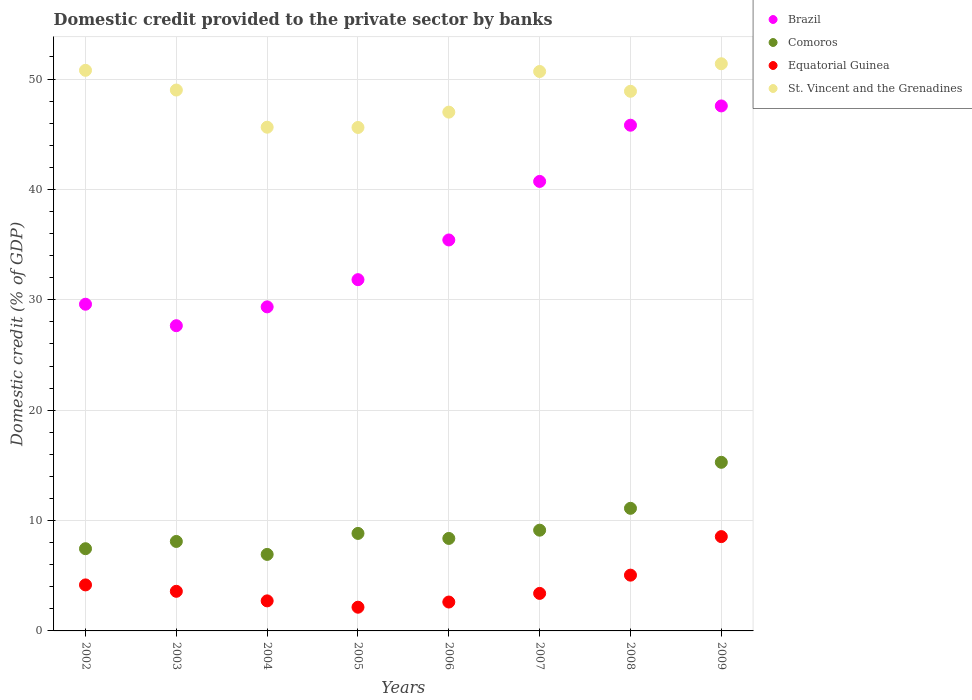What is the domestic credit provided to the private sector by banks in Equatorial Guinea in 2006?
Give a very brief answer. 2.62. Across all years, what is the maximum domestic credit provided to the private sector by banks in Brazil?
Ensure brevity in your answer.  47.56. Across all years, what is the minimum domestic credit provided to the private sector by banks in St. Vincent and the Grenadines?
Offer a terse response. 45.61. In which year was the domestic credit provided to the private sector by banks in Brazil minimum?
Offer a very short reply. 2003. What is the total domestic credit provided to the private sector by banks in Comoros in the graph?
Make the answer very short. 75.21. What is the difference between the domestic credit provided to the private sector by banks in Equatorial Guinea in 2002 and that in 2003?
Make the answer very short. 0.58. What is the difference between the domestic credit provided to the private sector by banks in Equatorial Guinea in 2009 and the domestic credit provided to the private sector by banks in Comoros in 2007?
Make the answer very short. -0.58. What is the average domestic credit provided to the private sector by banks in Brazil per year?
Keep it short and to the point. 35.99. In the year 2003, what is the difference between the domestic credit provided to the private sector by banks in Comoros and domestic credit provided to the private sector by banks in Brazil?
Your answer should be very brief. -19.55. In how many years, is the domestic credit provided to the private sector by banks in Equatorial Guinea greater than 28 %?
Provide a short and direct response. 0. What is the ratio of the domestic credit provided to the private sector by banks in Equatorial Guinea in 2005 to that in 2009?
Give a very brief answer. 0.25. What is the difference between the highest and the second highest domestic credit provided to the private sector by banks in Equatorial Guinea?
Provide a succinct answer. 3.49. What is the difference between the highest and the lowest domestic credit provided to the private sector by banks in St. Vincent and the Grenadines?
Your answer should be very brief. 5.77. In how many years, is the domestic credit provided to the private sector by banks in Equatorial Guinea greater than the average domestic credit provided to the private sector by banks in Equatorial Guinea taken over all years?
Offer a terse response. 3. Is it the case that in every year, the sum of the domestic credit provided to the private sector by banks in Equatorial Guinea and domestic credit provided to the private sector by banks in Brazil  is greater than the domestic credit provided to the private sector by banks in Comoros?
Offer a terse response. Yes. Is the domestic credit provided to the private sector by banks in Comoros strictly less than the domestic credit provided to the private sector by banks in Brazil over the years?
Provide a succinct answer. Yes. How many dotlines are there?
Provide a short and direct response. 4. How many years are there in the graph?
Provide a succinct answer. 8. What is the difference between two consecutive major ticks on the Y-axis?
Provide a succinct answer. 10. Are the values on the major ticks of Y-axis written in scientific E-notation?
Offer a very short reply. No. Where does the legend appear in the graph?
Give a very brief answer. Top right. How many legend labels are there?
Provide a short and direct response. 4. What is the title of the graph?
Keep it short and to the point. Domestic credit provided to the private sector by banks. What is the label or title of the Y-axis?
Provide a succinct answer. Domestic credit (% of GDP). What is the Domestic credit (% of GDP) in Brazil in 2002?
Make the answer very short. 29.6. What is the Domestic credit (% of GDP) of Comoros in 2002?
Your answer should be compact. 7.45. What is the Domestic credit (% of GDP) of Equatorial Guinea in 2002?
Offer a very short reply. 4.17. What is the Domestic credit (% of GDP) in St. Vincent and the Grenadines in 2002?
Your answer should be very brief. 50.79. What is the Domestic credit (% of GDP) of Brazil in 2003?
Offer a very short reply. 27.65. What is the Domestic credit (% of GDP) of Comoros in 2003?
Offer a terse response. 8.11. What is the Domestic credit (% of GDP) of Equatorial Guinea in 2003?
Keep it short and to the point. 3.59. What is the Domestic credit (% of GDP) of St. Vincent and the Grenadines in 2003?
Make the answer very short. 49. What is the Domestic credit (% of GDP) in Brazil in 2004?
Your response must be concise. 29.36. What is the Domestic credit (% of GDP) of Comoros in 2004?
Your response must be concise. 6.93. What is the Domestic credit (% of GDP) of Equatorial Guinea in 2004?
Keep it short and to the point. 2.72. What is the Domestic credit (% of GDP) in St. Vincent and the Grenadines in 2004?
Offer a terse response. 45.64. What is the Domestic credit (% of GDP) in Brazil in 2005?
Offer a very short reply. 31.82. What is the Domestic credit (% of GDP) in Comoros in 2005?
Provide a short and direct response. 8.83. What is the Domestic credit (% of GDP) of Equatorial Guinea in 2005?
Provide a short and direct response. 2.15. What is the Domestic credit (% of GDP) of St. Vincent and the Grenadines in 2005?
Ensure brevity in your answer.  45.61. What is the Domestic credit (% of GDP) of Brazil in 2006?
Offer a terse response. 35.42. What is the Domestic credit (% of GDP) of Comoros in 2006?
Offer a very short reply. 8.38. What is the Domestic credit (% of GDP) of Equatorial Guinea in 2006?
Offer a terse response. 2.62. What is the Domestic credit (% of GDP) in St. Vincent and the Grenadines in 2006?
Give a very brief answer. 47. What is the Domestic credit (% of GDP) in Brazil in 2007?
Make the answer very short. 40.72. What is the Domestic credit (% of GDP) in Comoros in 2007?
Your response must be concise. 9.13. What is the Domestic credit (% of GDP) in Equatorial Guinea in 2007?
Offer a terse response. 3.4. What is the Domestic credit (% of GDP) of St. Vincent and the Grenadines in 2007?
Make the answer very short. 50.68. What is the Domestic credit (% of GDP) in Brazil in 2008?
Offer a terse response. 45.82. What is the Domestic credit (% of GDP) of Comoros in 2008?
Give a very brief answer. 11.11. What is the Domestic credit (% of GDP) in Equatorial Guinea in 2008?
Your answer should be compact. 5.05. What is the Domestic credit (% of GDP) of St. Vincent and the Grenadines in 2008?
Keep it short and to the point. 48.89. What is the Domestic credit (% of GDP) of Brazil in 2009?
Your answer should be compact. 47.56. What is the Domestic credit (% of GDP) in Comoros in 2009?
Your response must be concise. 15.28. What is the Domestic credit (% of GDP) of Equatorial Guinea in 2009?
Keep it short and to the point. 8.54. What is the Domestic credit (% of GDP) in St. Vincent and the Grenadines in 2009?
Provide a succinct answer. 51.38. Across all years, what is the maximum Domestic credit (% of GDP) in Brazil?
Ensure brevity in your answer.  47.56. Across all years, what is the maximum Domestic credit (% of GDP) of Comoros?
Make the answer very short. 15.28. Across all years, what is the maximum Domestic credit (% of GDP) in Equatorial Guinea?
Provide a short and direct response. 8.54. Across all years, what is the maximum Domestic credit (% of GDP) in St. Vincent and the Grenadines?
Your response must be concise. 51.38. Across all years, what is the minimum Domestic credit (% of GDP) in Brazil?
Your answer should be very brief. 27.65. Across all years, what is the minimum Domestic credit (% of GDP) in Comoros?
Give a very brief answer. 6.93. Across all years, what is the minimum Domestic credit (% of GDP) in Equatorial Guinea?
Offer a terse response. 2.15. Across all years, what is the minimum Domestic credit (% of GDP) of St. Vincent and the Grenadines?
Ensure brevity in your answer.  45.61. What is the total Domestic credit (% of GDP) in Brazil in the graph?
Your response must be concise. 287.95. What is the total Domestic credit (% of GDP) in Comoros in the graph?
Your answer should be very brief. 75.21. What is the total Domestic credit (% of GDP) of Equatorial Guinea in the graph?
Give a very brief answer. 32.24. What is the total Domestic credit (% of GDP) of St. Vincent and the Grenadines in the graph?
Your answer should be compact. 389. What is the difference between the Domestic credit (% of GDP) in Brazil in 2002 and that in 2003?
Keep it short and to the point. 1.95. What is the difference between the Domestic credit (% of GDP) of Comoros in 2002 and that in 2003?
Keep it short and to the point. -0.66. What is the difference between the Domestic credit (% of GDP) of Equatorial Guinea in 2002 and that in 2003?
Your answer should be very brief. 0.58. What is the difference between the Domestic credit (% of GDP) in St. Vincent and the Grenadines in 2002 and that in 2003?
Offer a terse response. 1.79. What is the difference between the Domestic credit (% of GDP) of Brazil in 2002 and that in 2004?
Your answer should be compact. 0.24. What is the difference between the Domestic credit (% of GDP) in Comoros in 2002 and that in 2004?
Keep it short and to the point. 0.52. What is the difference between the Domestic credit (% of GDP) in Equatorial Guinea in 2002 and that in 2004?
Your answer should be compact. 1.45. What is the difference between the Domestic credit (% of GDP) in St. Vincent and the Grenadines in 2002 and that in 2004?
Offer a terse response. 5.15. What is the difference between the Domestic credit (% of GDP) of Brazil in 2002 and that in 2005?
Provide a short and direct response. -2.23. What is the difference between the Domestic credit (% of GDP) of Comoros in 2002 and that in 2005?
Provide a succinct answer. -1.39. What is the difference between the Domestic credit (% of GDP) in Equatorial Guinea in 2002 and that in 2005?
Give a very brief answer. 2.02. What is the difference between the Domestic credit (% of GDP) in St. Vincent and the Grenadines in 2002 and that in 2005?
Provide a succinct answer. 5.18. What is the difference between the Domestic credit (% of GDP) of Brazil in 2002 and that in 2006?
Ensure brevity in your answer.  -5.82. What is the difference between the Domestic credit (% of GDP) in Comoros in 2002 and that in 2006?
Ensure brevity in your answer.  -0.93. What is the difference between the Domestic credit (% of GDP) of Equatorial Guinea in 2002 and that in 2006?
Make the answer very short. 1.55. What is the difference between the Domestic credit (% of GDP) in St. Vincent and the Grenadines in 2002 and that in 2006?
Offer a very short reply. 3.79. What is the difference between the Domestic credit (% of GDP) in Brazil in 2002 and that in 2007?
Keep it short and to the point. -11.13. What is the difference between the Domestic credit (% of GDP) in Comoros in 2002 and that in 2007?
Offer a very short reply. -1.68. What is the difference between the Domestic credit (% of GDP) in Equatorial Guinea in 2002 and that in 2007?
Your answer should be very brief. 0.77. What is the difference between the Domestic credit (% of GDP) of St. Vincent and the Grenadines in 2002 and that in 2007?
Provide a short and direct response. 0.11. What is the difference between the Domestic credit (% of GDP) of Brazil in 2002 and that in 2008?
Provide a succinct answer. -16.22. What is the difference between the Domestic credit (% of GDP) in Comoros in 2002 and that in 2008?
Provide a succinct answer. -3.66. What is the difference between the Domestic credit (% of GDP) in Equatorial Guinea in 2002 and that in 2008?
Give a very brief answer. -0.88. What is the difference between the Domestic credit (% of GDP) in St. Vincent and the Grenadines in 2002 and that in 2008?
Make the answer very short. 1.9. What is the difference between the Domestic credit (% of GDP) in Brazil in 2002 and that in 2009?
Your answer should be compact. -17.97. What is the difference between the Domestic credit (% of GDP) in Comoros in 2002 and that in 2009?
Provide a succinct answer. -7.83. What is the difference between the Domestic credit (% of GDP) in Equatorial Guinea in 2002 and that in 2009?
Provide a short and direct response. -4.37. What is the difference between the Domestic credit (% of GDP) of St. Vincent and the Grenadines in 2002 and that in 2009?
Keep it short and to the point. -0.6. What is the difference between the Domestic credit (% of GDP) of Brazil in 2003 and that in 2004?
Offer a very short reply. -1.71. What is the difference between the Domestic credit (% of GDP) of Comoros in 2003 and that in 2004?
Offer a very short reply. 1.17. What is the difference between the Domestic credit (% of GDP) of Equatorial Guinea in 2003 and that in 2004?
Keep it short and to the point. 0.87. What is the difference between the Domestic credit (% of GDP) in St. Vincent and the Grenadines in 2003 and that in 2004?
Give a very brief answer. 3.37. What is the difference between the Domestic credit (% of GDP) in Brazil in 2003 and that in 2005?
Your answer should be compact. -4.17. What is the difference between the Domestic credit (% of GDP) of Comoros in 2003 and that in 2005?
Your answer should be compact. -0.73. What is the difference between the Domestic credit (% of GDP) in Equatorial Guinea in 2003 and that in 2005?
Provide a succinct answer. 1.44. What is the difference between the Domestic credit (% of GDP) in St. Vincent and the Grenadines in 2003 and that in 2005?
Give a very brief answer. 3.39. What is the difference between the Domestic credit (% of GDP) of Brazil in 2003 and that in 2006?
Provide a succinct answer. -7.77. What is the difference between the Domestic credit (% of GDP) of Comoros in 2003 and that in 2006?
Your answer should be very brief. -0.27. What is the difference between the Domestic credit (% of GDP) of Equatorial Guinea in 2003 and that in 2006?
Make the answer very short. 0.97. What is the difference between the Domestic credit (% of GDP) of St. Vincent and the Grenadines in 2003 and that in 2006?
Your response must be concise. 2. What is the difference between the Domestic credit (% of GDP) in Brazil in 2003 and that in 2007?
Provide a short and direct response. -13.07. What is the difference between the Domestic credit (% of GDP) in Comoros in 2003 and that in 2007?
Offer a terse response. -1.02. What is the difference between the Domestic credit (% of GDP) in Equatorial Guinea in 2003 and that in 2007?
Provide a succinct answer. 0.19. What is the difference between the Domestic credit (% of GDP) in St. Vincent and the Grenadines in 2003 and that in 2007?
Your answer should be compact. -1.68. What is the difference between the Domestic credit (% of GDP) in Brazil in 2003 and that in 2008?
Your response must be concise. -18.16. What is the difference between the Domestic credit (% of GDP) of Comoros in 2003 and that in 2008?
Give a very brief answer. -3. What is the difference between the Domestic credit (% of GDP) of Equatorial Guinea in 2003 and that in 2008?
Offer a terse response. -1.46. What is the difference between the Domestic credit (% of GDP) in St. Vincent and the Grenadines in 2003 and that in 2008?
Your response must be concise. 0.11. What is the difference between the Domestic credit (% of GDP) of Brazil in 2003 and that in 2009?
Provide a succinct answer. -19.91. What is the difference between the Domestic credit (% of GDP) of Comoros in 2003 and that in 2009?
Provide a short and direct response. -7.17. What is the difference between the Domestic credit (% of GDP) in Equatorial Guinea in 2003 and that in 2009?
Offer a very short reply. -4.96. What is the difference between the Domestic credit (% of GDP) of St. Vincent and the Grenadines in 2003 and that in 2009?
Keep it short and to the point. -2.38. What is the difference between the Domestic credit (% of GDP) in Brazil in 2004 and that in 2005?
Your answer should be very brief. -2.46. What is the difference between the Domestic credit (% of GDP) of Comoros in 2004 and that in 2005?
Your answer should be very brief. -1.9. What is the difference between the Domestic credit (% of GDP) in Equatorial Guinea in 2004 and that in 2005?
Keep it short and to the point. 0.57. What is the difference between the Domestic credit (% of GDP) in St. Vincent and the Grenadines in 2004 and that in 2005?
Ensure brevity in your answer.  0.02. What is the difference between the Domestic credit (% of GDP) of Brazil in 2004 and that in 2006?
Provide a succinct answer. -6.06. What is the difference between the Domestic credit (% of GDP) in Comoros in 2004 and that in 2006?
Your answer should be compact. -1.45. What is the difference between the Domestic credit (% of GDP) in Equatorial Guinea in 2004 and that in 2006?
Provide a short and direct response. 0.1. What is the difference between the Domestic credit (% of GDP) in St. Vincent and the Grenadines in 2004 and that in 2006?
Your answer should be very brief. -1.37. What is the difference between the Domestic credit (% of GDP) of Brazil in 2004 and that in 2007?
Provide a short and direct response. -11.37. What is the difference between the Domestic credit (% of GDP) of Comoros in 2004 and that in 2007?
Make the answer very short. -2.2. What is the difference between the Domestic credit (% of GDP) of Equatorial Guinea in 2004 and that in 2007?
Offer a terse response. -0.68. What is the difference between the Domestic credit (% of GDP) of St. Vincent and the Grenadines in 2004 and that in 2007?
Offer a terse response. -5.05. What is the difference between the Domestic credit (% of GDP) of Brazil in 2004 and that in 2008?
Provide a succinct answer. -16.46. What is the difference between the Domestic credit (% of GDP) in Comoros in 2004 and that in 2008?
Your answer should be very brief. -4.18. What is the difference between the Domestic credit (% of GDP) of Equatorial Guinea in 2004 and that in 2008?
Make the answer very short. -2.33. What is the difference between the Domestic credit (% of GDP) in St. Vincent and the Grenadines in 2004 and that in 2008?
Keep it short and to the point. -3.25. What is the difference between the Domestic credit (% of GDP) in Brazil in 2004 and that in 2009?
Your answer should be compact. -18.21. What is the difference between the Domestic credit (% of GDP) in Comoros in 2004 and that in 2009?
Your response must be concise. -8.34. What is the difference between the Domestic credit (% of GDP) in Equatorial Guinea in 2004 and that in 2009?
Your response must be concise. -5.82. What is the difference between the Domestic credit (% of GDP) of St. Vincent and the Grenadines in 2004 and that in 2009?
Keep it short and to the point. -5.75. What is the difference between the Domestic credit (% of GDP) in Brazil in 2005 and that in 2006?
Provide a short and direct response. -3.6. What is the difference between the Domestic credit (% of GDP) of Comoros in 2005 and that in 2006?
Keep it short and to the point. 0.45. What is the difference between the Domestic credit (% of GDP) in Equatorial Guinea in 2005 and that in 2006?
Provide a succinct answer. -0.47. What is the difference between the Domestic credit (% of GDP) of St. Vincent and the Grenadines in 2005 and that in 2006?
Your response must be concise. -1.39. What is the difference between the Domestic credit (% of GDP) of Brazil in 2005 and that in 2007?
Your response must be concise. -8.9. What is the difference between the Domestic credit (% of GDP) of Comoros in 2005 and that in 2007?
Offer a very short reply. -0.29. What is the difference between the Domestic credit (% of GDP) in Equatorial Guinea in 2005 and that in 2007?
Offer a very short reply. -1.25. What is the difference between the Domestic credit (% of GDP) in St. Vincent and the Grenadines in 2005 and that in 2007?
Your answer should be compact. -5.07. What is the difference between the Domestic credit (% of GDP) of Brazil in 2005 and that in 2008?
Keep it short and to the point. -13.99. What is the difference between the Domestic credit (% of GDP) in Comoros in 2005 and that in 2008?
Provide a succinct answer. -2.27. What is the difference between the Domestic credit (% of GDP) of Equatorial Guinea in 2005 and that in 2008?
Make the answer very short. -2.9. What is the difference between the Domestic credit (% of GDP) in St. Vincent and the Grenadines in 2005 and that in 2008?
Ensure brevity in your answer.  -3.28. What is the difference between the Domestic credit (% of GDP) in Brazil in 2005 and that in 2009?
Offer a terse response. -15.74. What is the difference between the Domestic credit (% of GDP) of Comoros in 2005 and that in 2009?
Offer a terse response. -6.44. What is the difference between the Domestic credit (% of GDP) of Equatorial Guinea in 2005 and that in 2009?
Keep it short and to the point. -6.4. What is the difference between the Domestic credit (% of GDP) in St. Vincent and the Grenadines in 2005 and that in 2009?
Give a very brief answer. -5.77. What is the difference between the Domestic credit (% of GDP) of Brazil in 2006 and that in 2007?
Offer a terse response. -5.3. What is the difference between the Domestic credit (% of GDP) in Comoros in 2006 and that in 2007?
Keep it short and to the point. -0.75. What is the difference between the Domestic credit (% of GDP) in Equatorial Guinea in 2006 and that in 2007?
Ensure brevity in your answer.  -0.78. What is the difference between the Domestic credit (% of GDP) in St. Vincent and the Grenadines in 2006 and that in 2007?
Offer a terse response. -3.68. What is the difference between the Domestic credit (% of GDP) of Brazil in 2006 and that in 2008?
Keep it short and to the point. -10.4. What is the difference between the Domestic credit (% of GDP) of Comoros in 2006 and that in 2008?
Your answer should be compact. -2.73. What is the difference between the Domestic credit (% of GDP) of Equatorial Guinea in 2006 and that in 2008?
Your response must be concise. -2.44. What is the difference between the Domestic credit (% of GDP) in St. Vincent and the Grenadines in 2006 and that in 2008?
Offer a terse response. -1.89. What is the difference between the Domestic credit (% of GDP) of Brazil in 2006 and that in 2009?
Make the answer very short. -12.14. What is the difference between the Domestic credit (% of GDP) of Comoros in 2006 and that in 2009?
Keep it short and to the point. -6.9. What is the difference between the Domestic credit (% of GDP) in Equatorial Guinea in 2006 and that in 2009?
Your answer should be compact. -5.93. What is the difference between the Domestic credit (% of GDP) in St. Vincent and the Grenadines in 2006 and that in 2009?
Make the answer very short. -4.38. What is the difference between the Domestic credit (% of GDP) in Brazil in 2007 and that in 2008?
Keep it short and to the point. -5.09. What is the difference between the Domestic credit (% of GDP) of Comoros in 2007 and that in 2008?
Provide a short and direct response. -1.98. What is the difference between the Domestic credit (% of GDP) of Equatorial Guinea in 2007 and that in 2008?
Give a very brief answer. -1.65. What is the difference between the Domestic credit (% of GDP) in St. Vincent and the Grenadines in 2007 and that in 2008?
Provide a short and direct response. 1.79. What is the difference between the Domestic credit (% of GDP) of Brazil in 2007 and that in 2009?
Offer a very short reply. -6.84. What is the difference between the Domestic credit (% of GDP) of Comoros in 2007 and that in 2009?
Keep it short and to the point. -6.15. What is the difference between the Domestic credit (% of GDP) of Equatorial Guinea in 2007 and that in 2009?
Your answer should be very brief. -5.14. What is the difference between the Domestic credit (% of GDP) of St. Vincent and the Grenadines in 2007 and that in 2009?
Your response must be concise. -0.7. What is the difference between the Domestic credit (% of GDP) of Brazil in 2008 and that in 2009?
Give a very brief answer. -1.75. What is the difference between the Domestic credit (% of GDP) in Comoros in 2008 and that in 2009?
Give a very brief answer. -4.17. What is the difference between the Domestic credit (% of GDP) of Equatorial Guinea in 2008 and that in 2009?
Provide a succinct answer. -3.49. What is the difference between the Domestic credit (% of GDP) in St. Vincent and the Grenadines in 2008 and that in 2009?
Keep it short and to the point. -2.49. What is the difference between the Domestic credit (% of GDP) of Brazil in 2002 and the Domestic credit (% of GDP) of Comoros in 2003?
Your answer should be very brief. 21.49. What is the difference between the Domestic credit (% of GDP) in Brazil in 2002 and the Domestic credit (% of GDP) in Equatorial Guinea in 2003?
Your response must be concise. 26.01. What is the difference between the Domestic credit (% of GDP) in Brazil in 2002 and the Domestic credit (% of GDP) in St. Vincent and the Grenadines in 2003?
Keep it short and to the point. -19.41. What is the difference between the Domestic credit (% of GDP) of Comoros in 2002 and the Domestic credit (% of GDP) of Equatorial Guinea in 2003?
Give a very brief answer. 3.86. What is the difference between the Domestic credit (% of GDP) in Comoros in 2002 and the Domestic credit (% of GDP) in St. Vincent and the Grenadines in 2003?
Provide a short and direct response. -41.55. What is the difference between the Domestic credit (% of GDP) in Equatorial Guinea in 2002 and the Domestic credit (% of GDP) in St. Vincent and the Grenadines in 2003?
Your answer should be very brief. -44.83. What is the difference between the Domestic credit (% of GDP) of Brazil in 2002 and the Domestic credit (% of GDP) of Comoros in 2004?
Make the answer very short. 22.67. What is the difference between the Domestic credit (% of GDP) of Brazil in 2002 and the Domestic credit (% of GDP) of Equatorial Guinea in 2004?
Provide a succinct answer. 26.88. What is the difference between the Domestic credit (% of GDP) in Brazil in 2002 and the Domestic credit (% of GDP) in St. Vincent and the Grenadines in 2004?
Provide a succinct answer. -16.04. What is the difference between the Domestic credit (% of GDP) in Comoros in 2002 and the Domestic credit (% of GDP) in Equatorial Guinea in 2004?
Make the answer very short. 4.73. What is the difference between the Domestic credit (% of GDP) in Comoros in 2002 and the Domestic credit (% of GDP) in St. Vincent and the Grenadines in 2004?
Your answer should be compact. -38.19. What is the difference between the Domestic credit (% of GDP) of Equatorial Guinea in 2002 and the Domestic credit (% of GDP) of St. Vincent and the Grenadines in 2004?
Keep it short and to the point. -41.47. What is the difference between the Domestic credit (% of GDP) in Brazil in 2002 and the Domestic credit (% of GDP) in Comoros in 2005?
Keep it short and to the point. 20.76. What is the difference between the Domestic credit (% of GDP) of Brazil in 2002 and the Domestic credit (% of GDP) of Equatorial Guinea in 2005?
Ensure brevity in your answer.  27.45. What is the difference between the Domestic credit (% of GDP) in Brazil in 2002 and the Domestic credit (% of GDP) in St. Vincent and the Grenadines in 2005?
Provide a short and direct response. -16.01. What is the difference between the Domestic credit (% of GDP) of Comoros in 2002 and the Domestic credit (% of GDP) of Equatorial Guinea in 2005?
Your answer should be compact. 5.3. What is the difference between the Domestic credit (% of GDP) of Comoros in 2002 and the Domestic credit (% of GDP) of St. Vincent and the Grenadines in 2005?
Make the answer very short. -38.16. What is the difference between the Domestic credit (% of GDP) in Equatorial Guinea in 2002 and the Domestic credit (% of GDP) in St. Vincent and the Grenadines in 2005?
Offer a terse response. -41.44. What is the difference between the Domestic credit (% of GDP) in Brazil in 2002 and the Domestic credit (% of GDP) in Comoros in 2006?
Offer a very short reply. 21.22. What is the difference between the Domestic credit (% of GDP) in Brazil in 2002 and the Domestic credit (% of GDP) in Equatorial Guinea in 2006?
Provide a short and direct response. 26.98. What is the difference between the Domestic credit (% of GDP) in Brazil in 2002 and the Domestic credit (% of GDP) in St. Vincent and the Grenadines in 2006?
Your answer should be compact. -17.4. What is the difference between the Domestic credit (% of GDP) in Comoros in 2002 and the Domestic credit (% of GDP) in Equatorial Guinea in 2006?
Offer a very short reply. 4.83. What is the difference between the Domestic credit (% of GDP) in Comoros in 2002 and the Domestic credit (% of GDP) in St. Vincent and the Grenadines in 2006?
Offer a very short reply. -39.55. What is the difference between the Domestic credit (% of GDP) of Equatorial Guinea in 2002 and the Domestic credit (% of GDP) of St. Vincent and the Grenadines in 2006?
Ensure brevity in your answer.  -42.83. What is the difference between the Domestic credit (% of GDP) of Brazil in 2002 and the Domestic credit (% of GDP) of Comoros in 2007?
Offer a very short reply. 20.47. What is the difference between the Domestic credit (% of GDP) of Brazil in 2002 and the Domestic credit (% of GDP) of Equatorial Guinea in 2007?
Provide a succinct answer. 26.2. What is the difference between the Domestic credit (% of GDP) in Brazil in 2002 and the Domestic credit (% of GDP) in St. Vincent and the Grenadines in 2007?
Offer a terse response. -21.09. What is the difference between the Domestic credit (% of GDP) in Comoros in 2002 and the Domestic credit (% of GDP) in Equatorial Guinea in 2007?
Give a very brief answer. 4.05. What is the difference between the Domestic credit (% of GDP) in Comoros in 2002 and the Domestic credit (% of GDP) in St. Vincent and the Grenadines in 2007?
Provide a succinct answer. -43.23. What is the difference between the Domestic credit (% of GDP) in Equatorial Guinea in 2002 and the Domestic credit (% of GDP) in St. Vincent and the Grenadines in 2007?
Provide a short and direct response. -46.51. What is the difference between the Domestic credit (% of GDP) in Brazil in 2002 and the Domestic credit (% of GDP) in Comoros in 2008?
Provide a short and direct response. 18.49. What is the difference between the Domestic credit (% of GDP) of Brazil in 2002 and the Domestic credit (% of GDP) of Equatorial Guinea in 2008?
Your answer should be very brief. 24.54. What is the difference between the Domestic credit (% of GDP) of Brazil in 2002 and the Domestic credit (% of GDP) of St. Vincent and the Grenadines in 2008?
Offer a very short reply. -19.29. What is the difference between the Domestic credit (% of GDP) in Comoros in 2002 and the Domestic credit (% of GDP) in Equatorial Guinea in 2008?
Your answer should be very brief. 2.4. What is the difference between the Domestic credit (% of GDP) of Comoros in 2002 and the Domestic credit (% of GDP) of St. Vincent and the Grenadines in 2008?
Make the answer very short. -41.44. What is the difference between the Domestic credit (% of GDP) of Equatorial Guinea in 2002 and the Domestic credit (% of GDP) of St. Vincent and the Grenadines in 2008?
Ensure brevity in your answer.  -44.72. What is the difference between the Domestic credit (% of GDP) in Brazil in 2002 and the Domestic credit (% of GDP) in Comoros in 2009?
Provide a short and direct response. 14.32. What is the difference between the Domestic credit (% of GDP) of Brazil in 2002 and the Domestic credit (% of GDP) of Equatorial Guinea in 2009?
Offer a very short reply. 21.05. What is the difference between the Domestic credit (% of GDP) in Brazil in 2002 and the Domestic credit (% of GDP) in St. Vincent and the Grenadines in 2009?
Make the answer very short. -21.79. What is the difference between the Domestic credit (% of GDP) of Comoros in 2002 and the Domestic credit (% of GDP) of Equatorial Guinea in 2009?
Offer a very short reply. -1.1. What is the difference between the Domestic credit (% of GDP) of Comoros in 2002 and the Domestic credit (% of GDP) of St. Vincent and the Grenadines in 2009?
Your response must be concise. -43.94. What is the difference between the Domestic credit (% of GDP) in Equatorial Guinea in 2002 and the Domestic credit (% of GDP) in St. Vincent and the Grenadines in 2009?
Your answer should be compact. -47.22. What is the difference between the Domestic credit (% of GDP) of Brazil in 2003 and the Domestic credit (% of GDP) of Comoros in 2004?
Offer a very short reply. 20.72. What is the difference between the Domestic credit (% of GDP) in Brazil in 2003 and the Domestic credit (% of GDP) in Equatorial Guinea in 2004?
Keep it short and to the point. 24.93. What is the difference between the Domestic credit (% of GDP) in Brazil in 2003 and the Domestic credit (% of GDP) in St. Vincent and the Grenadines in 2004?
Offer a very short reply. -17.98. What is the difference between the Domestic credit (% of GDP) in Comoros in 2003 and the Domestic credit (% of GDP) in Equatorial Guinea in 2004?
Provide a succinct answer. 5.38. What is the difference between the Domestic credit (% of GDP) of Comoros in 2003 and the Domestic credit (% of GDP) of St. Vincent and the Grenadines in 2004?
Provide a short and direct response. -37.53. What is the difference between the Domestic credit (% of GDP) in Equatorial Guinea in 2003 and the Domestic credit (% of GDP) in St. Vincent and the Grenadines in 2004?
Keep it short and to the point. -42.05. What is the difference between the Domestic credit (% of GDP) in Brazil in 2003 and the Domestic credit (% of GDP) in Comoros in 2005?
Your response must be concise. 18.82. What is the difference between the Domestic credit (% of GDP) of Brazil in 2003 and the Domestic credit (% of GDP) of Equatorial Guinea in 2005?
Your answer should be compact. 25.5. What is the difference between the Domestic credit (% of GDP) in Brazil in 2003 and the Domestic credit (% of GDP) in St. Vincent and the Grenadines in 2005?
Your answer should be compact. -17.96. What is the difference between the Domestic credit (% of GDP) of Comoros in 2003 and the Domestic credit (% of GDP) of Equatorial Guinea in 2005?
Your response must be concise. 5.96. What is the difference between the Domestic credit (% of GDP) of Comoros in 2003 and the Domestic credit (% of GDP) of St. Vincent and the Grenadines in 2005?
Your answer should be very brief. -37.51. What is the difference between the Domestic credit (% of GDP) in Equatorial Guinea in 2003 and the Domestic credit (% of GDP) in St. Vincent and the Grenadines in 2005?
Provide a short and direct response. -42.02. What is the difference between the Domestic credit (% of GDP) in Brazil in 2003 and the Domestic credit (% of GDP) in Comoros in 2006?
Provide a succinct answer. 19.27. What is the difference between the Domestic credit (% of GDP) in Brazil in 2003 and the Domestic credit (% of GDP) in Equatorial Guinea in 2006?
Offer a terse response. 25.03. What is the difference between the Domestic credit (% of GDP) in Brazil in 2003 and the Domestic credit (% of GDP) in St. Vincent and the Grenadines in 2006?
Make the answer very short. -19.35. What is the difference between the Domestic credit (% of GDP) of Comoros in 2003 and the Domestic credit (% of GDP) of Equatorial Guinea in 2006?
Keep it short and to the point. 5.49. What is the difference between the Domestic credit (% of GDP) of Comoros in 2003 and the Domestic credit (% of GDP) of St. Vincent and the Grenadines in 2006?
Keep it short and to the point. -38.9. What is the difference between the Domestic credit (% of GDP) in Equatorial Guinea in 2003 and the Domestic credit (% of GDP) in St. Vincent and the Grenadines in 2006?
Your answer should be very brief. -43.41. What is the difference between the Domestic credit (% of GDP) of Brazil in 2003 and the Domestic credit (% of GDP) of Comoros in 2007?
Your response must be concise. 18.52. What is the difference between the Domestic credit (% of GDP) in Brazil in 2003 and the Domestic credit (% of GDP) in Equatorial Guinea in 2007?
Make the answer very short. 24.25. What is the difference between the Domestic credit (% of GDP) in Brazil in 2003 and the Domestic credit (% of GDP) in St. Vincent and the Grenadines in 2007?
Provide a succinct answer. -23.03. What is the difference between the Domestic credit (% of GDP) in Comoros in 2003 and the Domestic credit (% of GDP) in Equatorial Guinea in 2007?
Your answer should be very brief. 4.71. What is the difference between the Domestic credit (% of GDP) of Comoros in 2003 and the Domestic credit (% of GDP) of St. Vincent and the Grenadines in 2007?
Provide a short and direct response. -42.58. What is the difference between the Domestic credit (% of GDP) of Equatorial Guinea in 2003 and the Domestic credit (% of GDP) of St. Vincent and the Grenadines in 2007?
Provide a succinct answer. -47.09. What is the difference between the Domestic credit (% of GDP) in Brazil in 2003 and the Domestic credit (% of GDP) in Comoros in 2008?
Give a very brief answer. 16.54. What is the difference between the Domestic credit (% of GDP) in Brazil in 2003 and the Domestic credit (% of GDP) in Equatorial Guinea in 2008?
Make the answer very short. 22.6. What is the difference between the Domestic credit (% of GDP) of Brazil in 2003 and the Domestic credit (% of GDP) of St. Vincent and the Grenadines in 2008?
Offer a terse response. -21.24. What is the difference between the Domestic credit (% of GDP) in Comoros in 2003 and the Domestic credit (% of GDP) in Equatorial Guinea in 2008?
Offer a terse response. 3.05. What is the difference between the Domestic credit (% of GDP) in Comoros in 2003 and the Domestic credit (% of GDP) in St. Vincent and the Grenadines in 2008?
Your response must be concise. -40.78. What is the difference between the Domestic credit (% of GDP) of Equatorial Guinea in 2003 and the Domestic credit (% of GDP) of St. Vincent and the Grenadines in 2008?
Ensure brevity in your answer.  -45.3. What is the difference between the Domestic credit (% of GDP) in Brazil in 2003 and the Domestic credit (% of GDP) in Comoros in 2009?
Your answer should be compact. 12.38. What is the difference between the Domestic credit (% of GDP) of Brazil in 2003 and the Domestic credit (% of GDP) of Equatorial Guinea in 2009?
Provide a succinct answer. 19.11. What is the difference between the Domestic credit (% of GDP) of Brazil in 2003 and the Domestic credit (% of GDP) of St. Vincent and the Grenadines in 2009?
Provide a succinct answer. -23.73. What is the difference between the Domestic credit (% of GDP) in Comoros in 2003 and the Domestic credit (% of GDP) in Equatorial Guinea in 2009?
Offer a very short reply. -0.44. What is the difference between the Domestic credit (% of GDP) of Comoros in 2003 and the Domestic credit (% of GDP) of St. Vincent and the Grenadines in 2009?
Your answer should be very brief. -43.28. What is the difference between the Domestic credit (% of GDP) in Equatorial Guinea in 2003 and the Domestic credit (% of GDP) in St. Vincent and the Grenadines in 2009?
Your answer should be compact. -47.8. What is the difference between the Domestic credit (% of GDP) in Brazil in 2004 and the Domestic credit (% of GDP) in Comoros in 2005?
Keep it short and to the point. 20.52. What is the difference between the Domestic credit (% of GDP) in Brazil in 2004 and the Domestic credit (% of GDP) in Equatorial Guinea in 2005?
Provide a succinct answer. 27.21. What is the difference between the Domestic credit (% of GDP) in Brazil in 2004 and the Domestic credit (% of GDP) in St. Vincent and the Grenadines in 2005?
Your answer should be very brief. -16.25. What is the difference between the Domestic credit (% of GDP) of Comoros in 2004 and the Domestic credit (% of GDP) of Equatorial Guinea in 2005?
Provide a succinct answer. 4.78. What is the difference between the Domestic credit (% of GDP) of Comoros in 2004 and the Domestic credit (% of GDP) of St. Vincent and the Grenadines in 2005?
Ensure brevity in your answer.  -38.68. What is the difference between the Domestic credit (% of GDP) in Equatorial Guinea in 2004 and the Domestic credit (% of GDP) in St. Vincent and the Grenadines in 2005?
Offer a very short reply. -42.89. What is the difference between the Domestic credit (% of GDP) of Brazil in 2004 and the Domestic credit (% of GDP) of Comoros in 2006?
Your answer should be very brief. 20.98. What is the difference between the Domestic credit (% of GDP) of Brazil in 2004 and the Domestic credit (% of GDP) of Equatorial Guinea in 2006?
Offer a very short reply. 26.74. What is the difference between the Domestic credit (% of GDP) of Brazil in 2004 and the Domestic credit (% of GDP) of St. Vincent and the Grenadines in 2006?
Offer a terse response. -17.64. What is the difference between the Domestic credit (% of GDP) of Comoros in 2004 and the Domestic credit (% of GDP) of Equatorial Guinea in 2006?
Keep it short and to the point. 4.31. What is the difference between the Domestic credit (% of GDP) of Comoros in 2004 and the Domestic credit (% of GDP) of St. Vincent and the Grenadines in 2006?
Offer a very short reply. -40.07. What is the difference between the Domestic credit (% of GDP) of Equatorial Guinea in 2004 and the Domestic credit (% of GDP) of St. Vincent and the Grenadines in 2006?
Provide a succinct answer. -44.28. What is the difference between the Domestic credit (% of GDP) in Brazil in 2004 and the Domestic credit (% of GDP) in Comoros in 2007?
Your answer should be compact. 20.23. What is the difference between the Domestic credit (% of GDP) of Brazil in 2004 and the Domestic credit (% of GDP) of Equatorial Guinea in 2007?
Provide a short and direct response. 25.96. What is the difference between the Domestic credit (% of GDP) in Brazil in 2004 and the Domestic credit (% of GDP) in St. Vincent and the Grenadines in 2007?
Your answer should be very brief. -21.32. What is the difference between the Domestic credit (% of GDP) in Comoros in 2004 and the Domestic credit (% of GDP) in Equatorial Guinea in 2007?
Ensure brevity in your answer.  3.53. What is the difference between the Domestic credit (% of GDP) in Comoros in 2004 and the Domestic credit (% of GDP) in St. Vincent and the Grenadines in 2007?
Your answer should be compact. -43.75. What is the difference between the Domestic credit (% of GDP) in Equatorial Guinea in 2004 and the Domestic credit (% of GDP) in St. Vincent and the Grenadines in 2007?
Provide a succinct answer. -47.96. What is the difference between the Domestic credit (% of GDP) of Brazil in 2004 and the Domestic credit (% of GDP) of Comoros in 2008?
Offer a very short reply. 18.25. What is the difference between the Domestic credit (% of GDP) of Brazil in 2004 and the Domestic credit (% of GDP) of Equatorial Guinea in 2008?
Your response must be concise. 24.31. What is the difference between the Domestic credit (% of GDP) in Brazil in 2004 and the Domestic credit (% of GDP) in St. Vincent and the Grenadines in 2008?
Offer a very short reply. -19.53. What is the difference between the Domestic credit (% of GDP) of Comoros in 2004 and the Domestic credit (% of GDP) of Equatorial Guinea in 2008?
Keep it short and to the point. 1.88. What is the difference between the Domestic credit (% of GDP) of Comoros in 2004 and the Domestic credit (% of GDP) of St. Vincent and the Grenadines in 2008?
Offer a very short reply. -41.96. What is the difference between the Domestic credit (% of GDP) of Equatorial Guinea in 2004 and the Domestic credit (% of GDP) of St. Vincent and the Grenadines in 2008?
Your answer should be compact. -46.17. What is the difference between the Domestic credit (% of GDP) of Brazil in 2004 and the Domestic credit (% of GDP) of Comoros in 2009?
Ensure brevity in your answer.  14.08. What is the difference between the Domestic credit (% of GDP) of Brazil in 2004 and the Domestic credit (% of GDP) of Equatorial Guinea in 2009?
Your response must be concise. 20.81. What is the difference between the Domestic credit (% of GDP) in Brazil in 2004 and the Domestic credit (% of GDP) in St. Vincent and the Grenadines in 2009?
Offer a terse response. -22.03. What is the difference between the Domestic credit (% of GDP) of Comoros in 2004 and the Domestic credit (% of GDP) of Equatorial Guinea in 2009?
Offer a terse response. -1.61. What is the difference between the Domestic credit (% of GDP) in Comoros in 2004 and the Domestic credit (% of GDP) in St. Vincent and the Grenadines in 2009?
Provide a short and direct response. -44.45. What is the difference between the Domestic credit (% of GDP) in Equatorial Guinea in 2004 and the Domestic credit (% of GDP) in St. Vincent and the Grenadines in 2009?
Provide a succinct answer. -48.66. What is the difference between the Domestic credit (% of GDP) in Brazil in 2005 and the Domestic credit (% of GDP) in Comoros in 2006?
Make the answer very short. 23.44. What is the difference between the Domestic credit (% of GDP) of Brazil in 2005 and the Domestic credit (% of GDP) of Equatorial Guinea in 2006?
Offer a terse response. 29.21. What is the difference between the Domestic credit (% of GDP) of Brazil in 2005 and the Domestic credit (% of GDP) of St. Vincent and the Grenadines in 2006?
Provide a succinct answer. -15.18. What is the difference between the Domestic credit (% of GDP) in Comoros in 2005 and the Domestic credit (% of GDP) in Equatorial Guinea in 2006?
Ensure brevity in your answer.  6.22. What is the difference between the Domestic credit (% of GDP) of Comoros in 2005 and the Domestic credit (% of GDP) of St. Vincent and the Grenadines in 2006?
Provide a succinct answer. -38.17. What is the difference between the Domestic credit (% of GDP) of Equatorial Guinea in 2005 and the Domestic credit (% of GDP) of St. Vincent and the Grenadines in 2006?
Keep it short and to the point. -44.85. What is the difference between the Domestic credit (% of GDP) in Brazil in 2005 and the Domestic credit (% of GDP) in Comoros in 2007?
Your response must be concise. 22.7. What is the difference between the Domestic credit (% of GDP) in Brazil in 2005 and the Domestic credit (% of GDP) in Equatorial Guinea in 2007?
Make the answer very short. 28.42. What is the difference between the Domestic credit (% of GDP) of Brazil in 2005 and the Domestic credit (% of GDP) of St. Vincent and the Grenadines in 2007?
Ensure brevity in your answer.  -18.86. What is the difference between the Domestic credit (% of GDP) in Comoros in 2005 and the Domestic credit (% of GDP) in Equatorial Guinea in 2007?
Offer a very short reply. 5.43. What is the difference between the Domestic credit (% of GDP) of Comoros in 2005 and the Domestic credit (% of GDP) of St. Vincent and the Grenadines in 2007?
Your answer should be very brief. -41.85. What is the difference between the Domestic credit (% of GDP) of Equatorial Guinea in 2005 and the Domestic credit (% of GDP) of St. Vincent and the Grenadines in 2007?
Provide a short and direct response. -48.53. What is the difference between the Domestic credit (% of GDP) of Brazil in 2005 and the Domestic credit (% of GDP) of Comoros in 2008?
Offer a very short reply. 20.72. What is the difference between the Domestic credit (% of GDP) in Brazil in 2005 and the Domestic credit (% of GDP) in Equatorial Guinea in 2008?
Ensure brevity in your answer.  26.77. What is the difference between the Domestic credit (% of GDP) of Brazil in 2005 and the Domestic credit (% of GDP) of St. Vincent and the Grenadines in 2008?
Offer a very short reply. -17.07. What is the difference between the Domestic credit (% of GDP) of Comoros in 2005 and the Domestic credit (% of GDP) of Equatorial Guinea in 2008?
Your answer should be very brief. 3.78. What is the difference between the Domestic credit (% of GDP) of Comoros in 2005 and the Domestic credit (% of GDP) of St. Vincent and the Grenadines in 2008?
Provide a succinct answer. -40.06. What is the difference between the Domestic credit (% of GDP) of Equatorial Guinea in 2005 and the Domestic credit (% of GDP) of St. Vincent and the Grenadines in 2008?
Make the answer very short. -46.74. What is the difference between the Domestic credit (% of GDP) of Brazil in 2005 and the Domestic credit (% of GDP) of Comoros in 2009?
Offer a terse response. 16.55. What is the difference between the Domestic credit (% of GDP) in Brazil in 2005 and the Domestic credit (% of GDP) in Equatorial Guinea in 2009?
Ensure brevity in your answer.  23.28. What is the difference between the Domestic credit (% of GDP) in Brazil in 2005 and the Domestic credit (% of GDP) in St. Vincent and the Grenadines in 2009?
Provide a short and direct response. -19.56. What is the difference between the Domestic credit (% of GDP) of Comoros in 2005 and the Domestic credit (% of GDP) of Equatorial Guinea in 2009?
Keep it short and to the point. 0.29. What is the difference between the Domestic credit (% of GDP) in Comoros in 2005 and the Domestic credit (% of GDP) in St. Vincent and the Grenadines in 2009?
Provide a short and direct response. -42.55. What is the difference between the Domestic credit (% of GDP) in Equatorial Guinea in 2005 and the Domestic credit (% of GDP) in St. Vincent and the Grenadines in 2009?
Your answer should be very brief. -49.24. What is the difference between the Domestic credit (% of GDP) in Brazil in 2006 and the Domestic credit (% of GDP) in Comoros in 2007?
Ensure brevity in your answer.  26.29. What is the difference between the Domestic credit (% of GDP) in Brazil in 2006 and the Domestic credit (% of GDP) in Equatorial Guinea in 2007?
Provide a succinct answer. 32.02. What is the difference between the Domestic credit (% of GDP) in Brazil in 2006 and the Domestic credit (% of GDP) in St. Vincent and the Grenadines in 2007?
Give a very brief answer. -15.26. What is the difference between the Domestic credit (% of GDP) in Comoros in 2006 and the Domestic credit (% of GDP) in Equatorial Guinea in 2007?
Make the answer very short. 4.98. What is the difference between the Domestic credit (% of GDP) in Comoros in 2006 and the Domestic credit (% of GDP) in St. Vincent and the Grenadines in 2007?
Offer a terse response. -42.3. What is the difference between the Domestic credit (% of GDP) of Equatorial Guinea in 2006 and the Domestic credit (% of GDP) of St. Vincent and the Grenadines in 2007?
Make the answer very short. -48.07. What is the difference between the Domestic credit (% of GDP) in Brazil in 2006 and the Domestic credit (% of GDP) in Comoros in 2008?
Ensure brevity in your answer.  24.31. What is the difference between the Domestic credit (% of GDP) in Brazil in 2006 and the Domestic credit (% of GDP) in Equatorial Guinea in 2008?
Make the answer very short. 30.37. What is the difference between the Domestic credit (% of GDP) in Brazil in 2006 and the Domestic credit (% of GDP) in St. Vincent and the Grenadines in 2008?
Offer a terse response. -13.47. What is the difference between the Domestic credit (% of GDP) of Comoros in 2006 and the Domestic credit (% of GDP) of Equatorial Guinea in 2008?
Give a very brief answer. 3.33. What is the difference between the Domestic credit (% of GDP) in Comoros in 2006 and the Domestic credit (% of GDP) in St. Vincent and the Grenadines in 2008?
Your answer should be very brief. -40.51. What is the difference between the Domestic credit (% of GDP) of Equatorial Guinea in 2006 and the Domestic credit (% of GDP) of St. Vincent and the Grenadines in 2008?
Provide a succinct answer. -46.27. What is the difference between the Domestic credit (% of GDP) in Brazil in 2006 and the Domestic credit (% of GDP) in Comoros in 2009?
Your response must be concise. 20.14. What is the difference between the Domestic credit (% of GDP) in Brazil in 2006 and the Domestic credit (% of GDP) in Equatorial Guinea in 2009?
Provide a short and direct response. 26.88. What is the difference between the Domestic credit (% of GDP) of Brazil in 2006 and the Domestic credit (% of GDP) of St. Vincent and the Grenadines in 2009?
Offer a terse response. -15.96. What is the difference between the Domestic credit (% of GDP) of Comoros in 2006 and the Domestic credit (% of GDP) of Equatorial Guinea in 2009?
Ensure brevity in your answer.  -0.16. What is the difference between the Domestic credit (% of GDP) in Comoros in 2006 and the Domestic credit (% of GDP) in St. Vincent and the Grenadines in 2009?
Provide a short and direct response. -43.01. What is the difference between the Domestic credit (% of GDP) of Equatorial Guinea in 2006 and the Domestic credit (% of GDP) of St. Vincent and the Grenadines in 2009?
Offer a very short reply. -48.77. What is the difference between the Domestic credit (% of GDP) of Brazil in 2007 and the Domestic credit (% of GDP) of Comoros in 2008?
Your response must be concise. 29.62. What is the difference between the Domestic credit (% of GDP) of Brazil in 2007 and the Domestic credit (% of GDP) of Equatorial Guinea in 2008?
Your answer should be compact. 35.67. What is the difference between the Domestic credit (% of GDP) in Brazil in 2007 and the Domestic credit (% of GDP) in St. Vincent and the Grenadines in 2008?
Your answer should be compact. -8.17. What is the difference between the Domestic credit (% of GDP) in Comoros in 2007 and the Domestic credit (% of GDP) in Equatorial Guinea in 2008?
Make the answer very short. 4.07. What is the difference between the Domestic credit (% of GDP) in Comoros in 2007 and the Domestic credit (% of GDP) in St. Vincent and the Grenadines in 2008?
Give a very brief answer. -39.76. What is the difference between the Domestic credit (% of GDP) in Equatorial Guinea in 2007 and the Domestic credit (% of GDP) in St. Vincent and the Grenadines in 2008?
Give a very brief answer. -45.49. What is the difference between the Domestic credit (% of GDP) of Brazil in 2007 and the Domestic credit (% of GDP) of Comoros in 2009?
Provide a short and direct response. 25.45. What is the difference between the Domestic credit (% of GDP) in Brazil in 2007 and the Domestic credit (% of GDP) in Equatorial Guinea in 2009?
Provide a short and direct response. 32.18. What is the difference between the Domestic credit (% of GDP) in Brazil in 2007 and the Domestic credit (% of GDP) in St. Vincent and the Grenadines in 2009?
Provide a succinct answer. -10.66. What is the difference between the Domestic credit (% of GDP) of Comoros in 2007 and the Domestic credit (% of GDP) of Equatorial Guinea in 2009?
Ensure brevity in your answer.  0.58. What is the difference between the Domestic credit (% of GDP) in Comoros in 2007 and the Domestic credit (% of GDP) in St. Vincent and the Grenadines in 2009?
Offer a very short reply. -42.26. What is the difference between the Domestic credit (% of GDP) in Equatorial Guinea in 2007 and the Domestic credit (% of GDP) in St. Vincent and the Grenadines in 2009?
Provide a short and direct response. -47.99. What is the difference between the Domestic credit (% of GDP) in Brazil in 2008 and the Domestic credit (% of GDP) in Comoros in 2009?
Provide a succinct answer. 30.54. What is the difference between the Domestic credit (% of GDP) of Brazil in 2008 and the Domestic credit (% of GDP) of Equatorial Guinea in 2009?
Your answer should be compact. 37.27. What is the difference between the Domestic credit (% of GDP) in Brazil in 2008 and the Domestic credit (% of GDP) in St. Vincent and the Grenadines in 2009?
Offer a very short reply. -5.57. What is the difference between the Domestic credit (% of GDP) in Comoros in 2008 and the Domestic credit (% of GDP) in Equatorial Guinea in 2009?
Offer a terse response. 2.56. What is the difference between the Domestic credit (% of GDP) of Comoros in 2008 and the Domestic credit (% of GDP) of St. Vincent and the Grenadines in 2009?
Provide a succinct answer. -40.28. What is the difference between the Domestic credit (% of GDP) in Equatorial Guinea in 2008 and the Domestic credit (% of GDP) in St. Vincent and the Grenadines in 2009?
Offer a very short reply. -46.33. What is the average Domestic credit (% of GDP) in Brazil per year?
Your answer should be compact. 35.99. What is the average Domestic credit (% of GDP) in Comoros per year?
Provide a short and direct response. 9.4. What is the average Domestic credit (% of GDP) in Equatorial Guinea per year?
Your answer should be compact. 4.03. What is the average Domestic credit (% of GDP) in St. Vincent and the Grenadines per year?
Provide a succinct answer. 48.62. In the year 2002, what is the difference between the Domestic credit (% of GDP) of Brazil and Domestic credit (% of GDP) of Comoros?
Ensure brevity in your answer.  22.15. In the year 2002, what is the difference between the Domestic credit (% of GDP) in Brazil and Domestic credit (% of GDP) in Equatorial Guinea?
Give a very brief answer. 25.43. In the year 2002, what is the difference between the Domestic credit (% of GDP) in Brazil and Domestic credit (% of GDP) in St. Vincent and the Grenadines?
Keep it short and to the point. -21.19. In the year 2002, what is the difference between the Domestic credit (% of GDP) in Comoros and Domestic credit (% of GDP) in Equatorial Guinea?
Your answer should be compact. 3.28. In the year 2002, what is the difference between the Domestic credit (% of GDP) in Comoros and Domestic credit (% of GDP) in St. Vincent and the Grenadines?
Provide a short and direct response. -43.34. In the year 2002, what is the difference between the Domestic credit (% of GDP) in Equatorial Guinea and Domestic credit (% of GDP) in St. Vincent and the Grenadines?
Give a very brief answer. -46.62. In the year 2003, what is the difference between the Domestic credit (% of GDP) of Brazil and Domestic credit (% of GDP) of Comoros?
Offer a terse response. 19.55. In the year 2003, what is the difference between the Domestic credit (% of GDP) in Brazil and Domestic credit (% of GDP) in Equatorial Guinea?
Make the answer very short. 24.06. In the year 2003, what is the difference between the Domestic credit (% of GDP) in Brazil and Domestic credit (% of GDP) in St. Vincent and the Grenadines?
Offer a very short reply. -21.35. In the year 2003, what is the difference between the Domestic credit (% of GDP) of Comoros and Domestic credit (% of GDP) of Equatorial Guinea?
Make the answer very short. 4.52. In the year 2003, what is the difference between the Domestic credit (% of GDP) of Comoros and Domestic credit (% of GDP) of St. Vincent and the Grenadines?
Your response must be concise. -40.9. In the year 2003, what is the difference between the Domestic credit (% of GDP) of Equatorial Guinea and Domestic credit (% of GDP) of St. Vincent and the Grenadines?
Give a very brief answer. -45.41. In the year 2004, what is the difference between the Domestic credit (% of GDP) of Brazil and Domestic credit (% of GDP) of Comoros?
Your answer should be compact. 22.43. In the year 2004, what is the difference between the Domestic credit (% of GDP) of Brazil and Domestic credit (% of GDP) of Equatorial Guinea?
Give a very brief answer. 26.64. In the year 2004, what is the difference between the Domestic credit (% of GDP) of Brazil and Domestic credit (% of GDP) of St. Vincent and the Grenadines?
Make the answer very short. -16.28. In the year 2004, what is the difference between the Domestic credit (% of GDP) in Comoros and Domestic credit (% of GDP) in Equatorial Guinea?
Keep it short and to the point. 4.21. In the year 2004, what is the difference between the Domestic credit (% of GDP) in Comoros and Domestic credit (% of GDP) in St. Vincent and the Grenadines?
Keep it short and to the point. -38.7. In the year 2004, what is the difference between the Domestic credit (% of GDP) in Equatorial Guinea and Domestic credit (% of GDP) in St. Vincent and the Grenadines?
Offer a very short reply. -42.91. In the year 2005, what is the difference between the Domestic credit (% of GDP) of Brazil and Domestic credit (% of GDP) of Comoros?
Your answer should be compact. 22.99. In the year 2005, what is the difference between the Domestic credit (% of GDP) of Brazil and Domestic credit (% of GDP) of Equatorial Guinea?
Make the answer very short. 29.67. In the year 2005, what is the difference between the Domestic credit (% of GDP) of Brazil and Domestic credit (% of GDP) of St. Vincent and the Grenadines?
Your response must be concise. -13.79. In the year 2005, what is the difference between the Domestic credit (% of GDP) in Comoros and Domestic credit (% of GDP) in Equatorial Guinea?
Ensure brevity in your answer.  6.69. In the year 2005, what is the difference between the Domestic credit (% of GDP) in Comoros and Domestic credit (% of GDP) in St. Vincent and the Grenadines?
Offer a very short reply. -36.78. In the year 2005, what is the difference between the Domestic credit (% of GDP) in Equatorial Guinea and Domestic credit (% of GDP) in St. Vincent and the Grenadines?
Your answer should be very brief. -43.46. In the year 2006, what is the difference between the Domestic credit (% of GDP) in Brazil and Domestic credit (% of GDP) in Comoros?
Provide a succinct answer. 27.04. In the year 2006, what is the difference between the Domestic credit (% of GDP) in Brazil and Domestic credit (% of GDP) in Equatorial Guinea?
Offer a terse response. 32.8. In the year 2006, what is the difference between the Domestic credit (% of GDP) in Brazil and Domestic credit (% of GDP) in St. Vincent and the Grenadines?
Provide a short and direct response. -11.58. In the year 2006, what is the difference between the Domestic credit (% of GDP) in Comoros and Domestic credit (% of GDP) in Equatorial Guinea?
Offer a terse response. 5.76. In the year 2006, what is the difference between the Domestic credit (% of GDP) in Comoros and Domestic credit (% of GDP) in St. Vincent and the Grenadines?
Ensure brevity in your answer.  -38.62. In the year 2006, what is the difference between the Domestic credit (% of GDP) of Equatorial Guinea and Domestic credit (% of GDP) of St. Vincent and the Grenadines?
Provide a short and direct response. -44.38. In the year 2007, what is the difference between the Domestic credit (% of GDP) of Brazil and Domestic credit (% of GDP) of Comoros?
Keep it short and to the point. 31.6. In the year 2007, what is the difference between the Domestic credit (% of GDP) of Brazil and Domestic credit (% of GDP) of Equatorial Guinea?
Your answer should be very brief. 37.32. In the year 2007, what is the difference between the Domestic credit (% of GDP) of Brazil and Domestic credit (% of GDP) of St. Vincent and the Grenadines?
Keep it short and to the point. -9.96. In the year 2007, what is the difference between the Domestic credit (% of GDP) of Comoros and Domestic credit (% of GDP) of Equatorial Guinea?
Ensure brevity in your answer.  5.73. In the year 2007, what is the difference between the Domestic credit (% of GDP) in Comoros and Domestic credit (% of GDP) in St. Vincent and the Grenadines?
Provide a short and direct response. -41.56. In the year 2007, what is the difference between the Domestic credit (% of GDP) in Equatorial Guinea and Domestic credit (% of GDP) in St. Vincent and the Grenadines?
Make the answer very short. -47.28. In the year 2008, what is the difference between the Domestic credit (% of GDP) in Brazil and Domestic credit (% of GDP) in Comoros?
Keep it short and to the point. 34.71. In the year 2008, what is the difference between the Domestic credit (% of GDP) of Brazil and Domestic credit (% of GDP) of Equatorial Guinea?
Make the answer very short. 40.76. In the year 2008, what is the difference between the Domestic credit (% of GDP) in Brazil and Domestic credit (% of GDP) in St. Vincent and the Grenadines?
Make the answer very short. -3.07. In the year 2008, what is the difference between the Domestic credit (% of GDP) of Comoros and Domestic credit (% of GDP) of Equatorial Guinea?
Provide a short and direct response. 6.05. In the year 2008, what is the difference between the Domestic credit (% of GDP) of Comoros and Domestic credit (% of GDP) of St. Vincent and the Grenadines?
Your answer should be very brief. -37.78. In the year 2008, what is the difference between the Domestic credit (% of GDP) in Equatorial Guinea and Domestic credit (% of GDP) in St. Vincent and the Grenadines?
Offer a very short reply. -43.84. In the year 2009, what is the difference between the Domestic credit (% of GDP) of Brazil and Domestic credit (% of GDP) of Comoros?
Provide a succinct answer. 32.29. In the year 2009, what is the difference between the Domestic credit (% of GDP) of Brazil and Domestic credit (% of GDP) of Equatorial Guinea?
Your response must be concise. 39.02. In the year 2009, what is the difference between the Domestic credit (% of GDP) of Brazil and Domestic credit (% of GDP) of St. Vincent and the Grenadines?
Provide a succinct answer. -3.82. In the year 2009, what is the difference between the Domestic credit (% of GDP) in Comoros and Domestic credit (% of GDP) in Equatorial Guinea?
Provide a succinct answer. 6.73. In the year 2009, what is the difference between the Domestic credit (% of GDP) in Comoros and Domestic credit (% of GDP) in St. Vincent and the Grenadines?
Your answer should be compact. -36.11. In the year 2009, what is the difference between the Domestic credit (% of GDP) in Equatorial Guinea and Domestic credit (% of GDP) in St. Vincent and the Grenadines?
Offer a very short reply. -42.84. What is the ratio of the Domestic credit (% of GDP) of Brazil in 2002 to that in 2003?
Provide a short and direct response. 1.07. What is the ratio of the Domestic credit (% of GDP) in Comoros in 2002 to that in 2003?
Your response must be concise. 0.92. What is the ratio of the Domestic credit (% of GDP) of Equatorial Guinea in 2002 to that in 2003?
Offer a terse response. 1.16. What is the ratio of the Domestic credit (% of GDP) in St. Vincent and the Grenadines in 2002 to that in 2003?
Your answer should be very brief. 1.04. What is the ratio of the Domestic credit (% of GDP) of Comoros in 2002 to that in 2004?
Ensure brevity in your answer.  1.07. What is the ratio of the Domestic credit (% of GDP) of Equatorial Guinea in 2002 to that in 2004?
Your answer should be very brief. 1.53. What is the ratio of the Domestic credit (% of GDP) of St. Vincent and the Grenadines in 2002 to that in 2004?
Provide a succinct answer. 1.11. What is the ratio of the Domestic credit (% of GDP) of Brazil in 2002 to that in 2005?
Make the answer very short. 0.93. What is the ratio of the Domestic credit (% of GDP) in Comoros in 2002 to that in 2005?
Give a very brief answer. 0.84. What is the ratio of the Domestic credit (% of GDP) of Equatorial Guinea in 2002 to that in 2005?
Make the answer very short. 1.94. What is the ratio of the Domestic credit (% of GDP) of St. Vincent and the Grenadines in 2002 to that in 2005?
Your response must be concise. 1.11. What is the ratio of the Domestic credit (% of GDP) in Brazil in 2002 to that in 2006?
Your response must be concise. 0.84. What is the ratio of the Domestic credit (% of GDP) in Comoros in 2002 to that in 2006?
Your answer should be compact. 0.89. What is the ratio of the Domestic credit (% of GDP) in Equatorial Guinea in 2002 to that in 2006?
Ensure brevity in your answer.  1.59. What is the ratio of the Domestic credit (% of GDP) in St. Vincent and the Grenadines in 2002 to that in 2006?
Ensure brevity in your answer.  1.08. What is the ratio of the Domestic credit (% of GDP) of Brazil in 2002 to that in 2007?
Your answer should be very brief. 0.73. What is the ratio of the Domestic credit (% of GDP) of Comoros in 2002 to that in 2007?
Keep it short and to the point. 0.82. What is the ratio of the Domestic credit (% of GDP) of Equatorial Guinea in 2002 to that in 2007?
Offer a terse response. 1.23. What is the ratio of the Domestic credit (% of GDP) of Brazil in 2002 to that in 2008?
Your response must be concise. 0.65. What is the ratio of the Domestic credit (% of GDP) in Comoros in 2002 to that in 2008?
Offer a very short reply. 0.67. What is the ratio of the Domestic credit (% of GDP) in Equatorial Guinea in 2002 to that in 2008?
Your response must be concise. 0.83. What is the ratio of the Domestic credit (% of GDP) of St. Vincent and the Grenadines in 2002 to that in 2008?
Give a very brief answer. 1.04. What is the ratio of the Domestic credit (% of GDP) in Brazil in 2002 to that in 2009?
Your answer should be compact. 0.62. What is the ratio of the Domestic credit (% of GDP) of Comoros in 2002 to that in 2009?
Provide a short and direct response. 0.49. What is the ratio of the Domestic credit (% of GDP) of Equatorial Guinea in 2002 to that in 2009?
Your answer should be compact. 0.49. What is the ratio of the Domestic credit (% of GDP) in St. Vincent and the Grenadines in 2002 to that in 2009?
Your answer should be very brief. 0.99. What is the ratio of the Domestic credit (% of GDP) of Brazil in 2003 to that in 2004?
Your answer should be very brief. 0.94. What is the ratio of the Domestic credit (% of GDP) of Comoros in 2003 to that in 2004?
Make the answer very short. 1.17. What is the ratio of the Domestic credit (% of GDP) of Equatorial Guinea in 2003 to that in 2004?
Your answer should be compact. 1.32. What is the ratio of the Domestic credit (% of GDP) of St. Vincent and the Grenadines in 2003 to that in 2004?
Your answer should be compact. 1.07. What is the ratio of the Domestic credit (% of GDP) in Brazil in 2003 to that in 2005?
Your answer should be very brief. 0.87. What is the ratio of the Domestic credit (% of GDP) of Comoros in 2003 to that in 2005?
Offer a terse response. 0.92. What is the ratio of the Domestic credit (% of GDP) of Equatorial Guinea in 2003 to that in 2005?
Your response must be concise. 1.67. What is the ratio of the Domestic credit (% of GDP) in St. Vincent and the Grenadines in 2003 to that in 2005?
Ensure brevity in your answer.  1.07. What is the ratio of the Domestic credit (% of GDP) in Brazil in 2003 to that in 2006?
Offer a very short reply. 0.78. What is the ratio of the Domestic credit (% of GDP) in Comoros in 2003 to that in 2006?
Your answer should be compact. 0.97. What is the ratio of the Domestic credit (% of GDP) of Equatorial Guinea in 2003 to that in 2006?
Make the answer very short. 1.37. What is the ratio of the Domestic credit (% of GDP) in St. Vincent and the Grenadines in 2003 to that in 2006?
Give a very brief answer. 1.04. What is the ratio of the Domestic credit (% of GDP) in Brazil in 2003 to that in 2007?
Provide a succinct answer. 0.68. What is the ratio of the Domestic credit (% of GDP) of Comoros in 2003 to that in 2007?
Provide a short and direct response. 0.89. What is the ratio of the Domestic credit (% of GDP) in Equatorial Guinea in 2003 to that in 2007?
Offer a terse response. 1.06. What is the ratio of the Domestic credit (% of GDP) of St. Vincent and the Grenadines in 2003 to that in 2007?
Make the answer very short. 0.97. What is the ratio of the Domestic credit (% of GDP) of Brazil in 2003 to that in 2008?
Give a very brief answer. 0.6. What is the ratio of the Domestic credit (% of GDP) of Comoros in 2003 to that in 2008?
Offer a terse response. 0.73. What is the ratio of the Domestic credit (% of GDP) in Equatorial Guinea in 2003 to that in 2008?
Ensure brevity in your answer.  0.71. What is the ratio of the Domestic credit (% of GDP) in Brazil in 2003 to that in 2009?
Provide a succinct answer. 0.58. What is the ratio of the Domestic credit (% of GDP) of Comoros in 2003 to that in 2009?
Provide a short and direct response. 0.53. What is the ratio of the Domestic credit (% of GDP) in Equatorial Guinea in 2003 to that in 2009?
Keep it short and to the point. 0.42. What is the ratio of the Domestic credit (% of GDP) in St. Vincent and the Grenadines in 2003 to that in 2009?
Keep it short and to the point. 0.95. What is the ratio of the Domestic credit (% of GDP) of Brazil in 2004 to that in 2005?
Make the answer very short. 0.92. What is the ratio of the Domestic credit (% of GDP) in Comoros in 2004 to that in 2005?
Give a very brief answer. 0.78. What is the ratio of the Domestic credit (% of GDP) of Equatorial Guinea in 2004 to that in 2005?
Your response must be concise. 1.27. What is the ratio of the Domestic credit (% of GDP) of St. Vincent and the Grenadines in 2004 to that in 2005?
Make the answer very short. 1. What is the ratio of the Domestic credit (% of GDP) in Brazil in 2004 to that in 2006?
Offer a very short reply. 0.83. What is the ratio of the Domestic credit (% of GDP) of Comoros in 2004 to that in 2006?
Your answer should be very brief. 0.83. What is the ratio of the Domestic credit (% of GDP) in Equatorial Guinea in 2004 to that in 2006?
Your answer should be compact. 1.04. What is the ratio of the Domestic credit (% of GDP) of St. Vincent and the Grenadines in 2004 to that in 2006?
Provide a short and direct response. 0.97. What is the ratio of the Domestic credit (% of GDP) of Brazil in 2004 to that in 2007?
Keep it short and to the point. 0.72. What is the ratio of the Domestic credit (% of GDP) in Comoros in 2004 to that in 2007?
Offer a very short reply. 0.76. What is the ratio of the Domestic credit (% of GDP) of Equatorial Guinea in 2004 to that in 2007?
Give a very brief answer. 0.8. What is the ratio of the Domestic credit (% of GDP) in St. Vincent and the Grenadines in 2004 to that in 2007?
Offer a terse response. 0.9. What is the ratio of the Domestic credit (% of GDP) in Brazil in 2004 to that in 2008?
Ensure brevity in your answer.  0.64. What is the ratio of the Domestic credit (% of GDP) in Comoros in 2004 to that in 2008?
Your response must be concise. 0.62. What is the ratio of the Domestic credit (% of GDP) in Equatorial Guinea in 2004 to that in 2008?
Keep it short and to the point. 0.54. What is the ratio of the Domestic credit (% of GDP) of St. Vincent and the Grenadines in 2004 to that in 2008?
Make the answer very short. 0.93. What is the ratio of the Domestic credit (% of GDP) of Brazil in 2004 to that in 2009?
Offer a very short reply. 0.62. What is the ratio of the Domestic credit (% of GDP) of Comoros in 2004 to that in 2009?
Your response must be concise. 0.45. What is the ratio of the Domestic credit (% of GDP) in Equatorial Guinea in 2004 to that in 2009?
Make the answer very short. 0.32. What is the ratio of the Domestic credit (% of GDP) of St. Vincent and the Grenadines in 2004 to that in 2009?
Provide a short and direct response. 0.89. What is the ratio of the Domestic credit (% of GDP) in Brazil in 2005 to that in 2006?
Ensure brevity in your answer.  0.9. What is the ratio of the Domestic credit (% of GDP) of Comoros in 2005 to that in 2006?
Provide a succinct answer. 1.05. What is the ratio of the Domestic credit (% of GDP) in Equatorial Guinea in 2005 to that in 2006?
Your answer should be very brief. 0.82. What is the ratio of the Domestic credit (% of GDP) in St. Vincent and the Grenadines in 2005 to that in 2006?
Give a very brief answer. 0.97. What is the ratio of the Domestic credit (% of GDP) in Brazil in 2005 to that in 2007?
Offer a terse response. 0.78. What is the ratio of the Domestic credit (% of GDP) of Comoros in 2005 to that in 2007?
Your answer should be compact. 0.97. What is the ratio of the Domestic credit (% of GDP) of Equatorial Guinea in 2005 to that in 2007?
Your answer should be very brief. 0.63. What is the ratio of the Domestic credit (% of GDP) of St. Vincent and the Grenadines in 2005 to that in 2007?
Offer a very short reply. 0.9. What is the ratio of the Domestic credit (% of GDP) in Brazil in 2005 to that in 2008?
Give a very brief answer. 0.69. What is the ratio of the Domestic credit (% of GDP) of Comoros in 2005 to that in 2008?
Ensure brevity in your answer.  0.8. What is the ratio of the Domestic credit (% of GDP) in Equatorial Guinea in 2005 to that in 2008?
Provide a succinct answer. 0.43. What is the ratio of the Domestic credit (% of GDP) of St. Vincent and the Grenadines in 2005 to that in 2008?
Give a very brief answer. 0.93. What is the ratio of the Domestic credit (% of GDP) of Brazil in 2005 to that in 2009?
Offer a very short reply. 0.67. What is the ratio of the Domestic credit (% of GDP) in Comoros in 2005 to that in 2009?
Provide a succinct answer. 0.58. What is the ratio of the Domestic credit (% of GDP) of Equatorial Guinea in 2005 to that in 2009?
Give a very brief answer. 0.25. What is the ratio of the Domestic credit (% of GDP) of St. Vincent and the Grenadines in 2005 to that in 2009?
Provide a succinct answer. 0.89. What is the ratio of the Domestic credit (% of GDP) of Brazil in 2006 to that in 2007?
Make the answer very short. 0.87. What is the ratio of the Domestic credit (% of GDP) of Comoros in 2006 to that in 2007?
Make the answer very short. 0.92. What is the ratio of the Domestic credit (% of GDP) in Equatorial Guinea in 2006 to that in 2007?
Your answer should be compact. 0.77. What is the ratio of the Domestic credit (% of GDP) of St. Vincent and the Grenadines in 2006 to that in 2007?
Your answer should be compact. 0.93. What is the ratio of the Domestic credit (% of GDP) of Brazil in 2006 to that in 2008?
Make the answer very short. 0.77. What is the ratio of the Domestic credit (% of GDP) of Comoros in 2006 to that in 2008?
Your answer should be very brief. 0.75. What is the ratio of the Domestic credit (% of GDP) of Equatorial Guinea in 2006 to that in 2008?
Offer a terse response. 0.52. What is the ratio of the Domestic credit (% of GDP) of St. Vincent and the Grenadines in 2006 to that in 2008?
Offer a very short reply. 0.96. What is the ratio of the Domestic credit (% of GDP) in Brazil in 2006 to that in 2009?
Your response must be concise. 0.74. What is the ratio of the Domestic credit (% of GDP) in Comoros in 2006 to that in 2009?
Offer a very short reply. 0.55. What is the ratio of the Domestic credit (% of GDP) in Equatorial Guinea in 2006 to that in 2009?
Keep it short and to the point. 0.31. What is the ratio of the Domestic credit (% of GDP) in St. Vincent and the Grenadines in 2006 to that in 2009?
Provide a short and direct response. 0.91. What is the ratio of the Domestic credit (% of GDP) of Brazil in 2007 to that in 2008?
Offer a terse response. 0.89. What is the ratio of the Domestic credit (% of GDP) of Comoros in 2007 to that in 2008?
Your answer should be compact. 0.82. What is the ratio of the Domestic credit (% of GDP) of Equatorial Guinea in 2007 to that in 2008?
Provide a succinct answer. 0.67. What is the ratio of the Domestic credit (% of GDP) of St. Vincent and the Grenadines in 2007 to that in 2008?
Your answer should be very brief. 1.04. What is the ratio of the Domestic credit (% of GDP) of Brazil in 2007 to that in 2009?
Your answer should be compact. 0.86. What is the ratio of the Domestic credit (% of GDP) of Comoros in 2007 to that in 2009?
Make the answer very short. 0.6. What is the ratio of the Domestic credit (% of GDP) in Equatorial Guinea in 2007 to that in 2009?
Make the answer very short. 0.4. What is the ratio of the Domestic credit (% of GDP) of St. Vincent and the Grenadines in 2007 to that in 2009?
Your answer should be very brief. 0.99. What is the ratio of the Domestic credit (% of GDP) of Brazil in 2008 to that in 2009?
Ensure brevity in your answer.  0.96. What is the ratio of the Domestic credit (% of GDP) of Comoros in 2008 to that in 2009?
Provide a short and direct response. 0.73. What is the ratio of the Domestic credit (% of GDP) of Equatorial Guinea in 2008 to that in 2009?
Provide a succinct answer. 0.59. What is the ratio of the Domestic credit (% of GDP) in St. Vincent and the Grenadines in 2008 to that in 2009?
Your answer should be compact. 0.95. What is the difference between the highest and the second highest Domestic credit (% of GDP) of Brazil?
Provide a short and direct response. 1.75. What is the difference between the highest and the second highest Domestic credit (% of GDP) of Comoros?
Your response must be concise. 4.17. What is the difference between the highest and the second highest Domestic credit (% of GDP) in Equatorial Guinea?
Your answer should be very brief. 3.49. What is the difference between the highest and the second highest Domestic credit (% of GDP) in St. Vincent and the Grenadines?
Keep it short and to the point. 0.6. What is the difference between the highest and the lowest Domestic credit (% of GDP) in Brazil?
Make the answer very short. 19.91. What is the difference between the highest and the lowest Domestic credit (% of GDP) in Comoros?
Your response must be concise. 8.34. What is the difference between the highest and the lowest Domestic credit (% of GDP) of Equatorial Guinea?
Offer a terse response. 6.4. What is the difference between the highest and the lowest Domestic credit (% of GDP) of St. Vincent and the Grenadines?
Offer a very short reply. 5.77. 